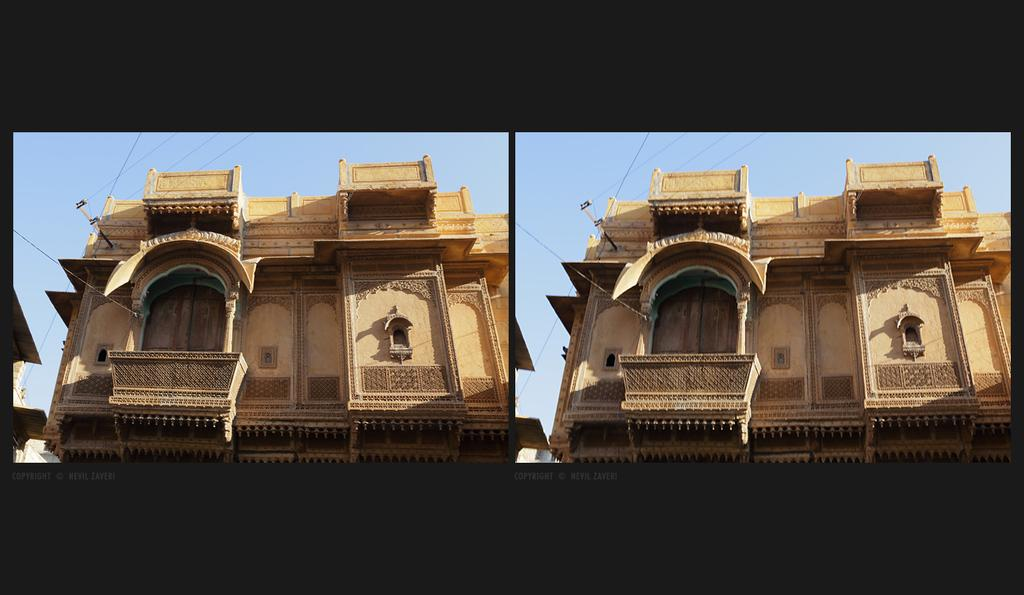What is the composition of the image? The image is a collage of two same pictures. What structure can be seen in the image? There is a building in the image. What color is the background of the image? The background of the image is blue. What type of soap is being used to clean the hair in the image? There is no soap or hair present in the image; it features a collage of two same pictures with a building and a blue background. 